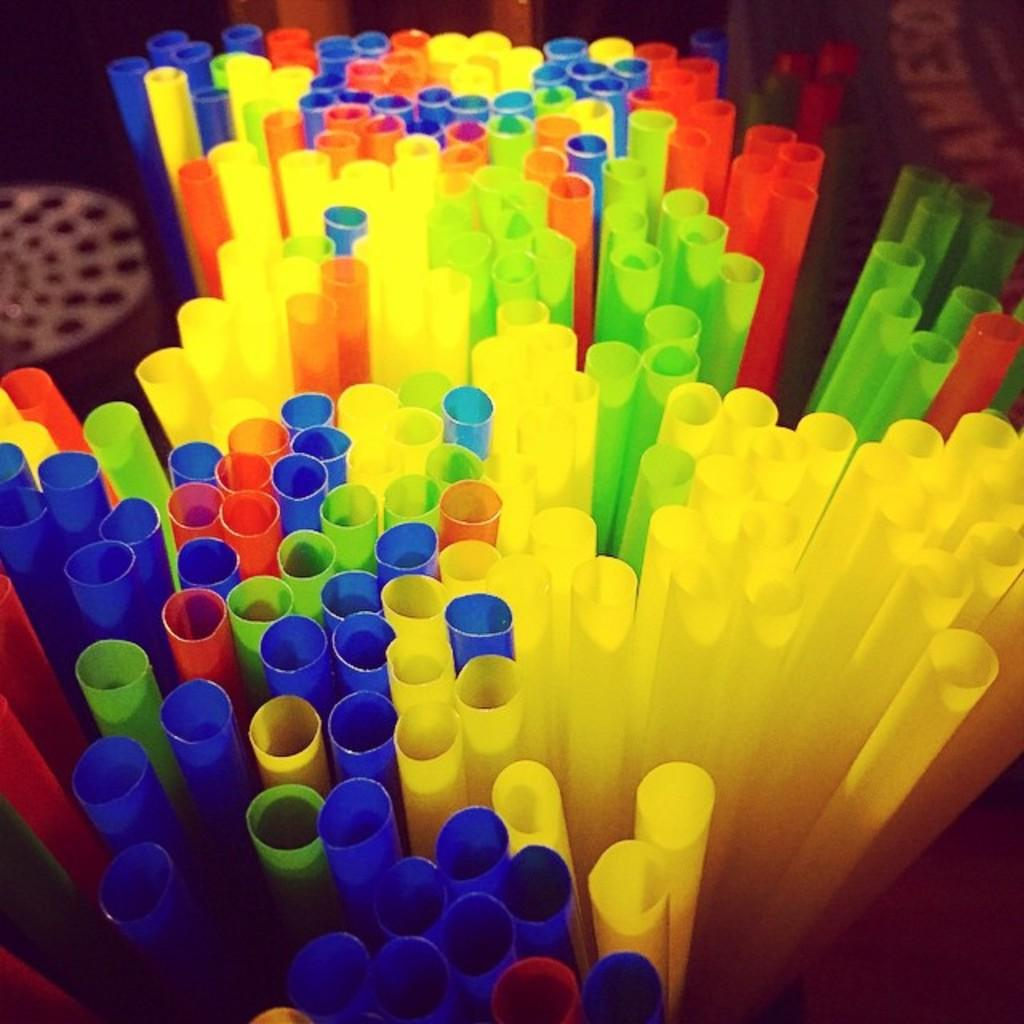What type of objects can be seen in the image? There are colorful objects in the image, which appear to be straws. Can you describe any other items visible in the image? There are other items visible in the background of the image, but their details are not clear from the provided facts. What type of weather can be seen in the image? There is no weather visible in the image, as it only features colorful objects that appear to be straws and other unspecified items in the background. 